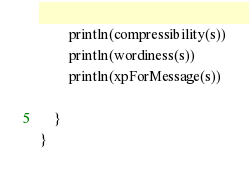Convert code to text. <code><loc_0><loc_0><loc_500><loc_500><_Kotlin_>        println(compressibility(s))
        println(wordiness(s))
        println(xpForMessage(s))

    }
}
</code> 